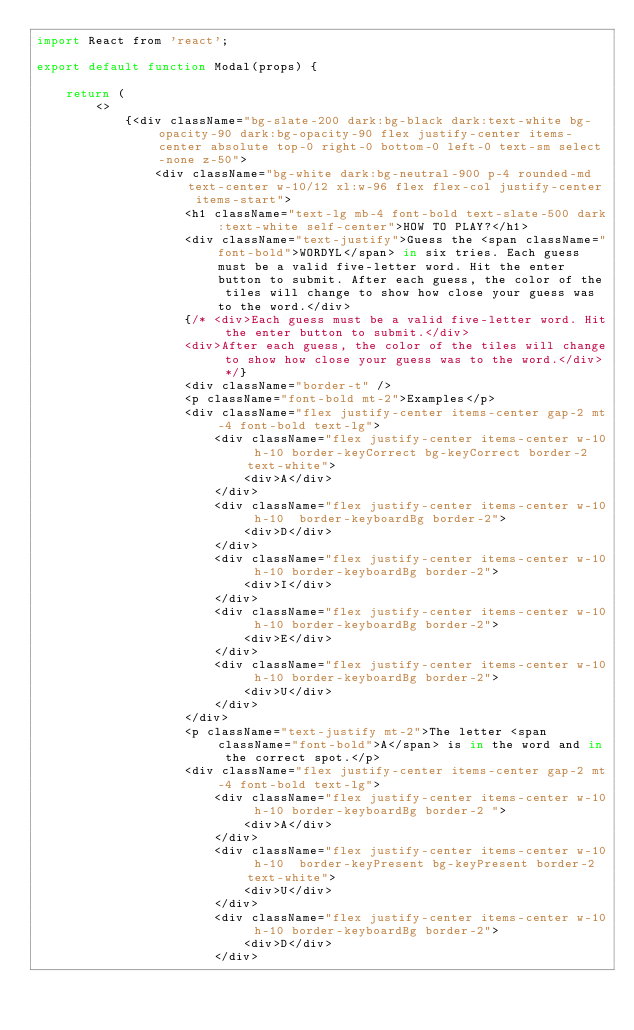Convert code to text. <code><loc_0><loc_0><loc_500><loc_500><_JavaScript_>import React from 'react';

export default function Modal(props) {

    return (
        <>
            {<div className="bg-slate-200 dark:bg-black dark:text-white bg-opacity-90 dark:bg-opacity-90 flex justify-center items-center absolute top-0 right-0 bottom-0 left-0 text-sm select-none z-50">
                <div className="bg-white dark:bg-neutral-900 p-4 rounded-md text-center w-10/12 xl:w-96 flex flex-col justify-center items-start">
                    <h1 className="text-lg mb-4 font-bold text-slate-500 dark:text-white self-center">HOW TO PLAY?</h1>
                    <div className="text-justify">Guess the <span className="font-bold">WORDYL</span> in six tries. Each guess must be a valid five-letter word. Hit the enter button to submit. After each guess, the color of the tiles will change to show how close your guess was to the word.</div>
                    {/* <div>Each guess must be a valid five-letter word. Hit the enter button to submit.</div>
                    <div>After each guess, the color of the tiles will change to show how close your guess was to the word.</div> */}
                    <div className="border-t" />
                    <p className="font-bold mt-2">Examples</p>
                    <div className="flex justify-center items-center gap-2 mt-4 font-bold text-lg">
                        <div className="flex justify-center items-center w-10 h-10 border-keyCorrect bg-keyCorrect border-2 text-white">
                            <div>A</div>
                        </div>
                        <div className="flex justify-center items-center w-10 h-10  border-keyboardBg border-2">
                            <div>D</div>
                        </div>
                        <div className="flex justify-center items-center w-10 h-10 border-keyboardBg border-2">
                            <div>I</div>
                        </div>
                        <div className="flex justify-center items-center w-10 h-10 border-keyboardBg border-2">
                            <div>E</div>
                        </div>
                        <div className="flex justify-center items-center w-10 h-10 border-keyboardBg border-2">
                            <div>U</div>
                        </div>
                    </div>
                    <p className="text-justify mt-2">The letter <span className="font-bold">A</span> is in the word and in the correct spot.</p>
                    <div className="flex justify-center items-center gap-2 mt-4 font-bold text-lg">
                        <div className="flex justify-center items-center w-10 h-10 border-keyboardBg border-2 ">
                            <div>A</div>
                        </div>
                        <div className="flex justify-center items-center w-10 h-10  border-keyPresent bg-keyPresent border-2 text-white">
                            <div>U</div>
                        </div>
                        <div className="flex justify-center items-center w-10 h-10 border-keyboardBg border-2">
                            <div>D</div>
                        </div></code> 